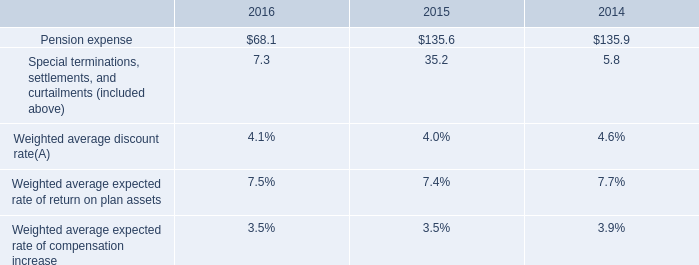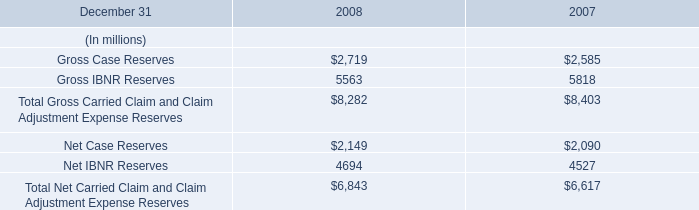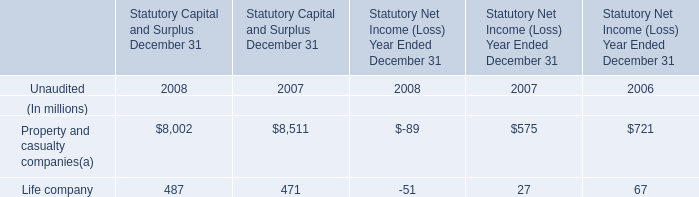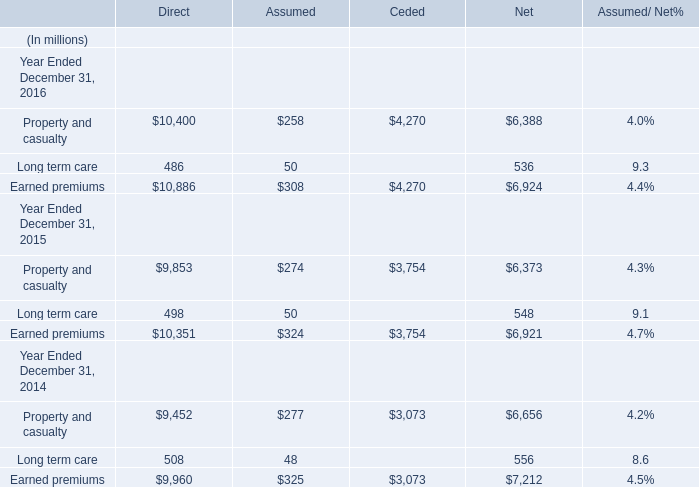considering the years 2015-2016 , what is the decrease observed in the cash contributions to funded plans and benefit payments for unfunded plans? 
Computations: ((79.3 - 137.5) / 137.5)
Answer: -0.42327. 